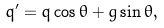<formula> <loc_0><loc_0><loc_500><loc_500>q ^ { \prime } = q \cos \theta + g \sin \theta ,</formula> 